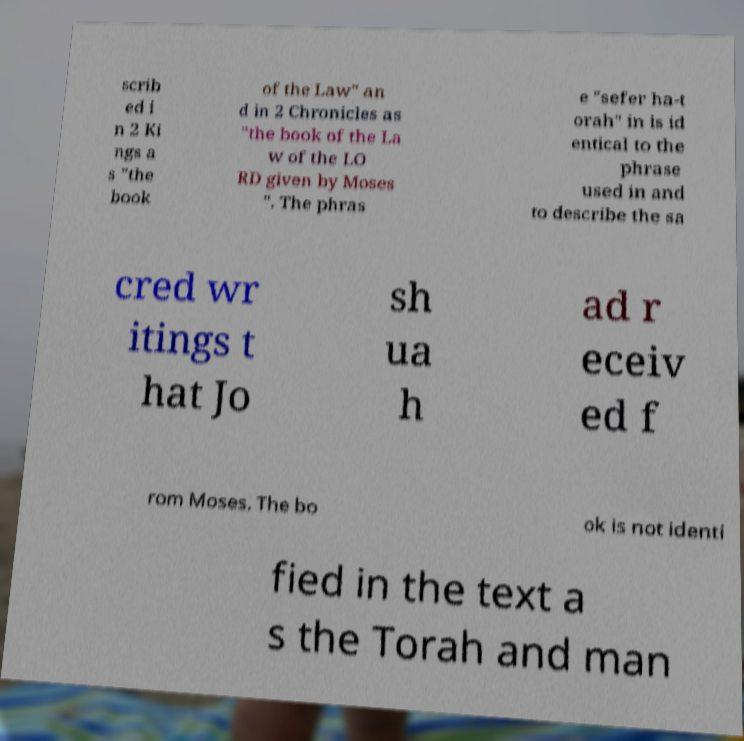Could you assist in decoding the text presented in this image and type it out clearly? scrib ed i n 2 Ki ngs a s "the book of the Law" an d in 2 Chronicles as "the book of the La w of the LO RD given by Moses ". The phras e "sefer ha-t orah" in is id entical to the phrase used in and to describe the sa cred wr itings t hat Jo sh ua h ad r eceiv ed f rom Moses. The bo ok is not identi fied in the text a s the Torah and man 